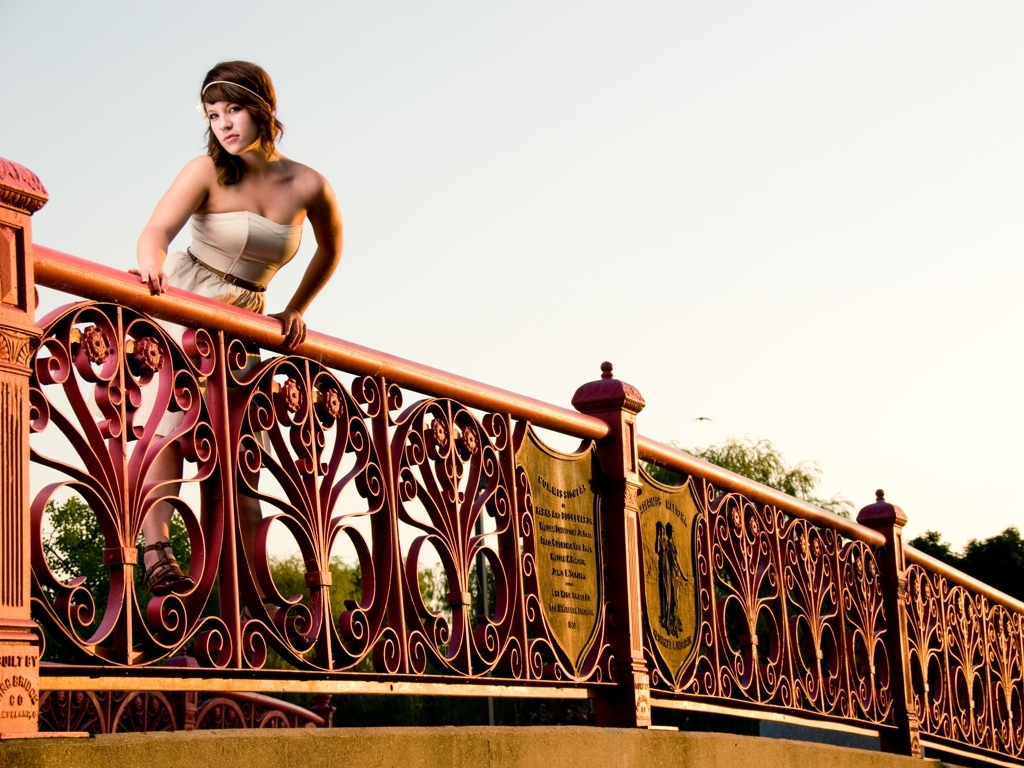What time of day does this photo seem to be taken, and how does it affect the mood of the image? The warm lighting and long shadows suggest that the photo was likely taken during the golden hour, which is shortly after sunrise or before sunset. This imparts a serene and warm mood to the image, highlighting the subject's contemplative expression and the intricate details of the railing. 